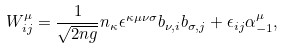<formula> <loc_0><loc_0><loc_500><loc_500>W ^ { \mu } _ { i j } = \frac { 1 } { \sqrt { 2 n g } } n _ { \kappa } \epsilon ^ { \kappa \mu \nu \sigma } b _ { \nu , i } b _ { \sigma , j } + \epsilon _ { i j } \alpha _ { - 1 } ^ { \mu } ,</formula> 